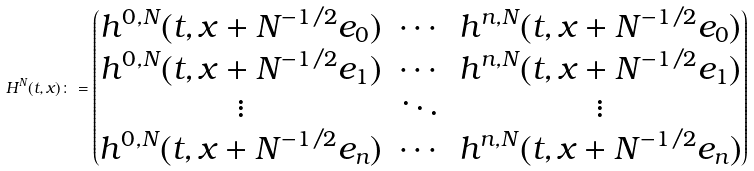<formula> <loc_0><loc_0><loc_500><loc_500>H ^ { N } ( t , x ) \colon = \begin{pmatrix} h ^ { 0 , N } ( t , x + N ^ { - 1 / 2 } e _ { 0 } ) & \cdots & h ^ { n , N } ( t , x + N ^ { - 1 / 2 } e _ { 0 } ) \\ h ^ { 0 , N } ( t , x + N ^ { - 1 / 2 } e _ { 1 } ) & \cdots & h ^ { n , N } ( t , x + N ^ { - 1 / 2 } e _ { 1 } ) \\ \vdots & \ddots & \vdots \\ h ^ { 0 , N } ( t , x + N ^ { - 1 / 2 } e _ { n } ) & \cdots & h ^ { n , N } ( t , x + N ^ { - 1 / 2 } e _ { n } ) \end{pmatrix}</formula> 